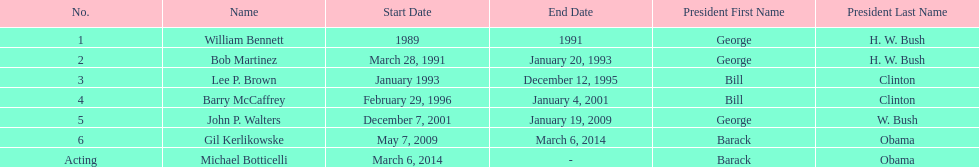What were the number of directors that stayed in office more than three years? 3. 